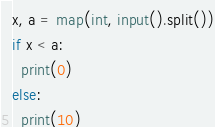Convert code to text. <code><loc_0><loc_0><loc_500><loc_500><_Python_>x, a = map(int, input().split())
if x < a:
  print(0)
else:
  print(10)</code> 